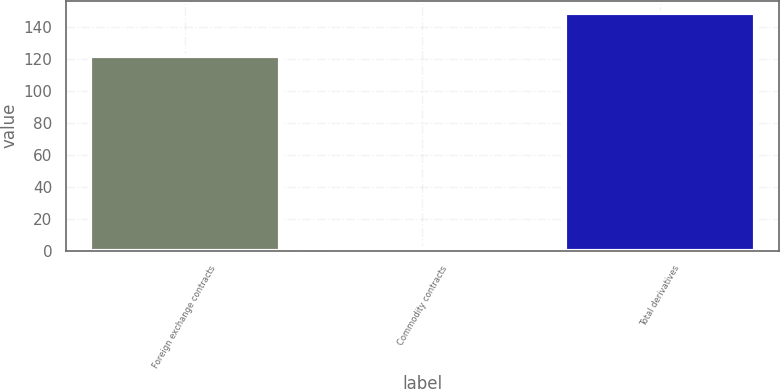Convert chart to OTSL. <chart><loc_0><loc_0><loc_500><loc_500><bar_chart><fcel>Foreign exchange contracts<fcel>Commodity contracts<fcel>Total derivatives<nl><fcel>122<fcel>2<fcel>149<nl></chart> 